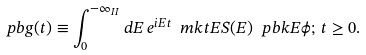Convert formula to latex. <formula><loc_0><loc_0><loc_500><loc_500>\ p b g ( t ) \equiv \int _ { 0 } ^ { - \infty _ { I I } } d E \, e ^ { i E t } \ m k t { E } S ( E ) \ p b k { E } { \phi } ; \, t \geq 0 .</formula> 